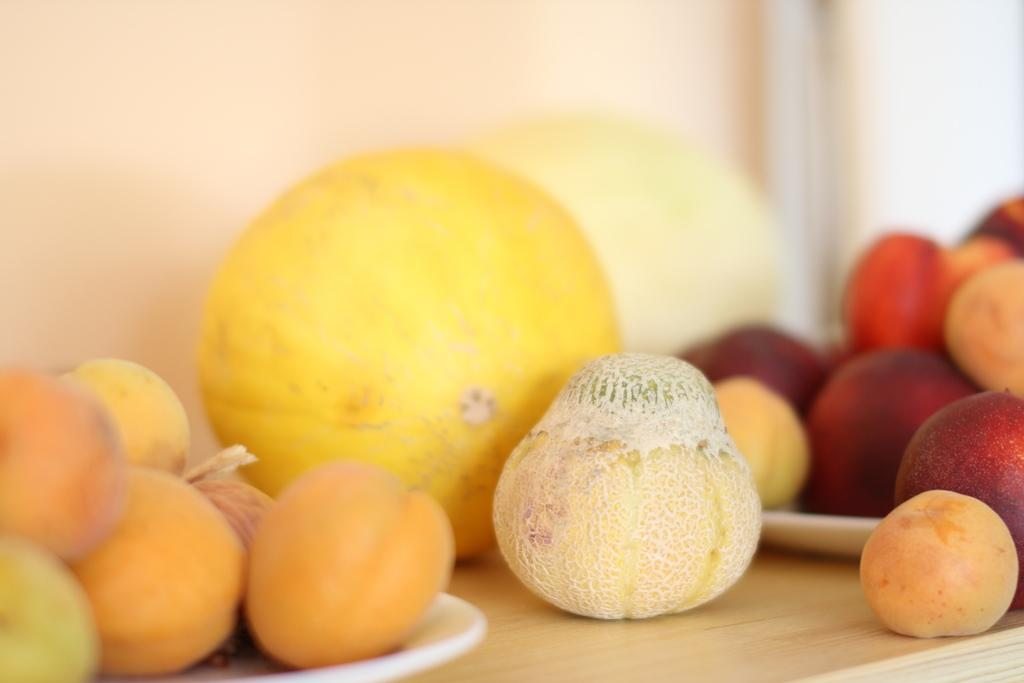What type of table is in the image? There is a wooden table in the image. What is placed on the wooden table? There are fruits on the table. Are there any additional items on the table? Yes, there are trays on the table. What is on the trays? There are fruits on the trays. What type of plant is growing on the table in the image? There is no plant growing on the table in the image; it only contains fruits and trays. 